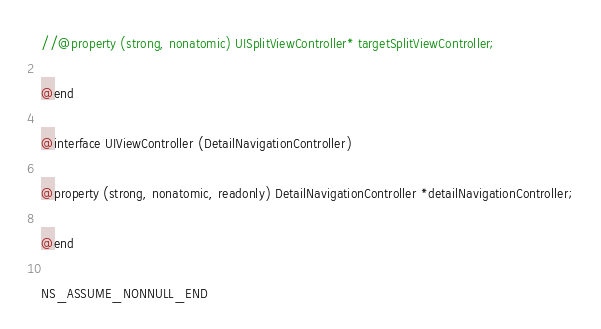<code> <loc_0><loc_0><loc_500><loc_500><_C_>
//@property (strong, nonatomic) UISplitViewController* targetSplitViewController;

@end

@interface UIViewController (DetailNavigationController)

@property (strong, nonatomic, readonly) DetailNavigationController *detailNavigationController;

@end

NS_ASSUME_NONNULL_END
</code> 